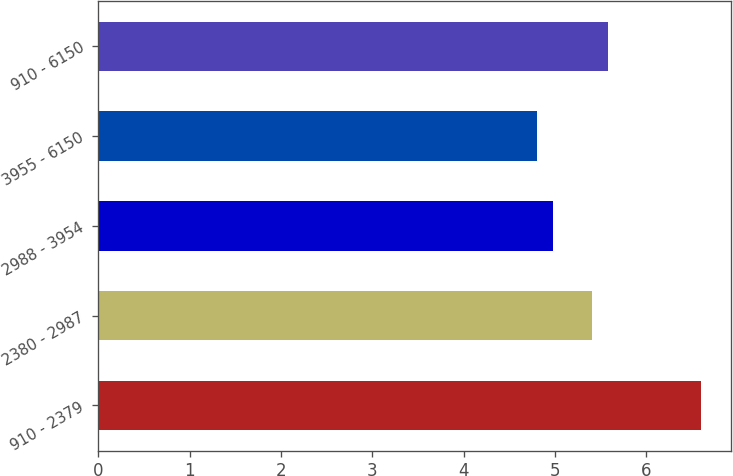<chart> <loc_0><loc_0><loc_500><loc_500><bar_chart><fcel>910 - 2379<fcel>2380 - 2987<fcel>2988 - 3954<fcel>3955 - 6150<fcel>910 - 6150<nl><fcel>6.6<fcel>5.4<fcel>4.98<fcel>4.8<fcel>5.58<nl></chart> 